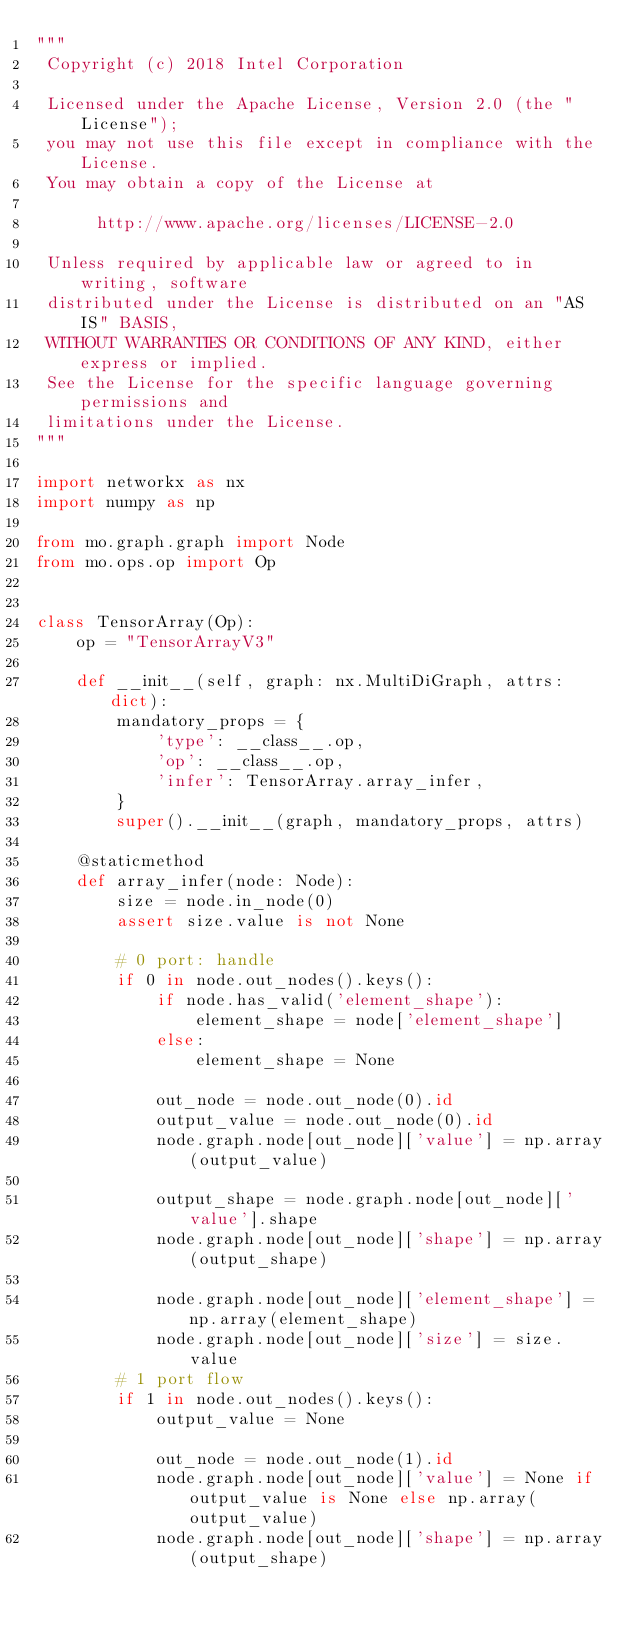Convert code to text. <code><loc_0><loc_0><loc_500><loc_500><_Python_>"""
 Copyright (c) 2018 Intel Corporation

 Licensed under the Apache License, Version 2.0 (the "License");
 you may not use this file except in compliance with the License.
 You may obtain a copy of the License at

      http://www.apache.org/licenses/LICENSE-2.0

 Unless required by applicable law or agreed to in writing, software
 distributed under the License is distributed on an "AS IS" BASIS,
 WITHOUT WARRANTIES OR CONDITIONS OF ANY KIND, either express or implied.
 See the License for the specific language governing permissions and
 limitations under the License.
"""

import networkx as nx
import numpy as np

from mo.graph.graph import Node
from mo.ops.op import Op


class TensorArray(Op):
    op = "TensorArrayV3"

    def __init__(self, graph: nx.MultiDiGraph, attrs: dict):
        mandatory_props = {
            'type': __class__.op,
            'op': __class__.op,
            'infer': TensorArray.array_infer,
        }
        super().__init__(graph, mandatory_props, attrs)

    @staticmethod
    def array_infer(node: Node):
        size = node.in_node(0)
        assert size.value is not None

        # 0 port: handle
        if 0 in node.out_nodes().keys():
            if node.has_valid('element_shape'):
                element_shape = node['element_shape']
            else:
                element_shape = None

            out_node = node.out_node(0).id
            output_value = node.out_node(0).id
            node.graph.node[out_node]['value'] = np.array(output_value)

            output_shape = node.graph.node[out_node]['value'].shape
            node.graph.node[out_node]['shape'] = np.array(output_shape)

            node.graph.node[out_node]['element_shape'] = np.array(element_shape)
            node.graph.node[out_node]['size'] = size.value
        # 1 port flow
        if 1 in node.out_nodes().keys():
            output_value = None

            out_node = node.out_node(1).id
            node.graph.node[out_node]['value'] = None if output_value is None else np.array(output_value)
            node.graph.node[out_node]['shape'] = np.array(output_shape)
</code> 